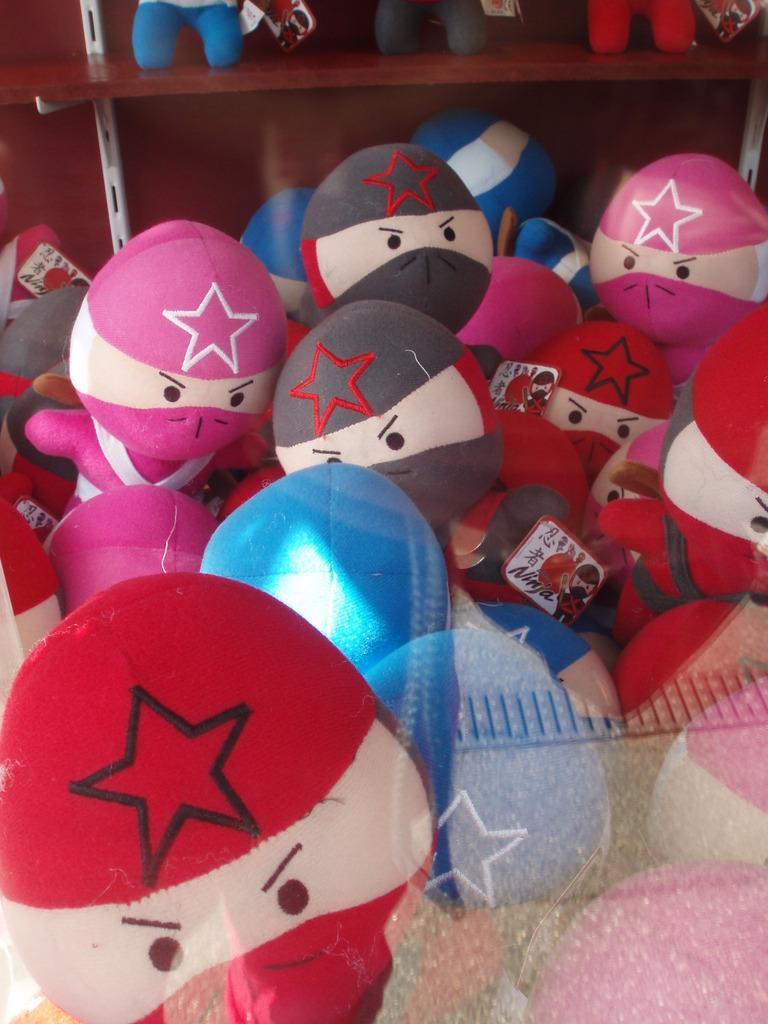In one or two sentences, can you explain what this image depicts? There are many toys. In the background there is a cupboard. Inside that there are toys. 